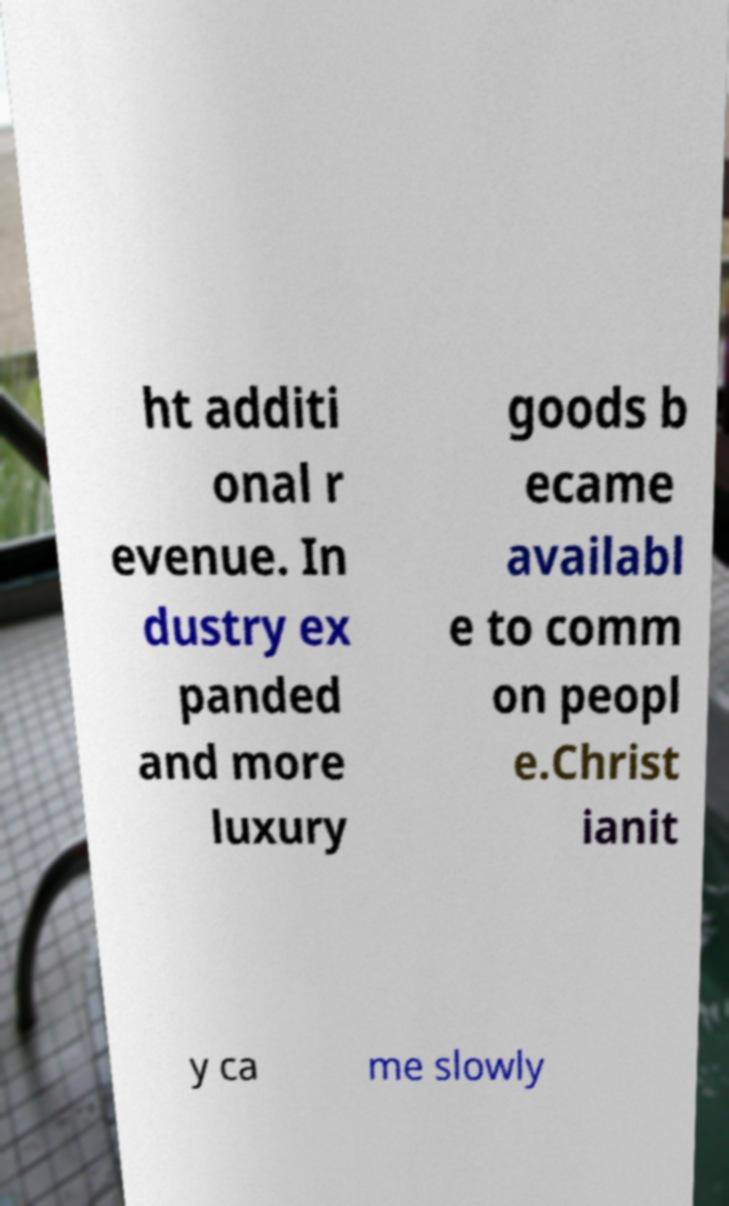Could you extract and type out the text from this image? ht additi onal r evenue. In dustry ex panded and more luxury goods b ecame availabl e to comm on peopl e.Christ ianit y ca me slowly 